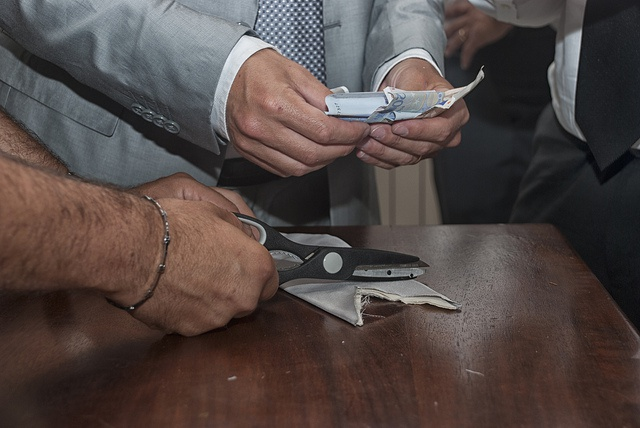Describe the objects in this image and their specific colors. I can see dining table in gray, maroon, and black tones, people in gray, black, and darkgray tones, people in gray, brown, and maroon tones, people in gray, black, and darkgray tones, and people in gray, black, and maroon tones in this image. 